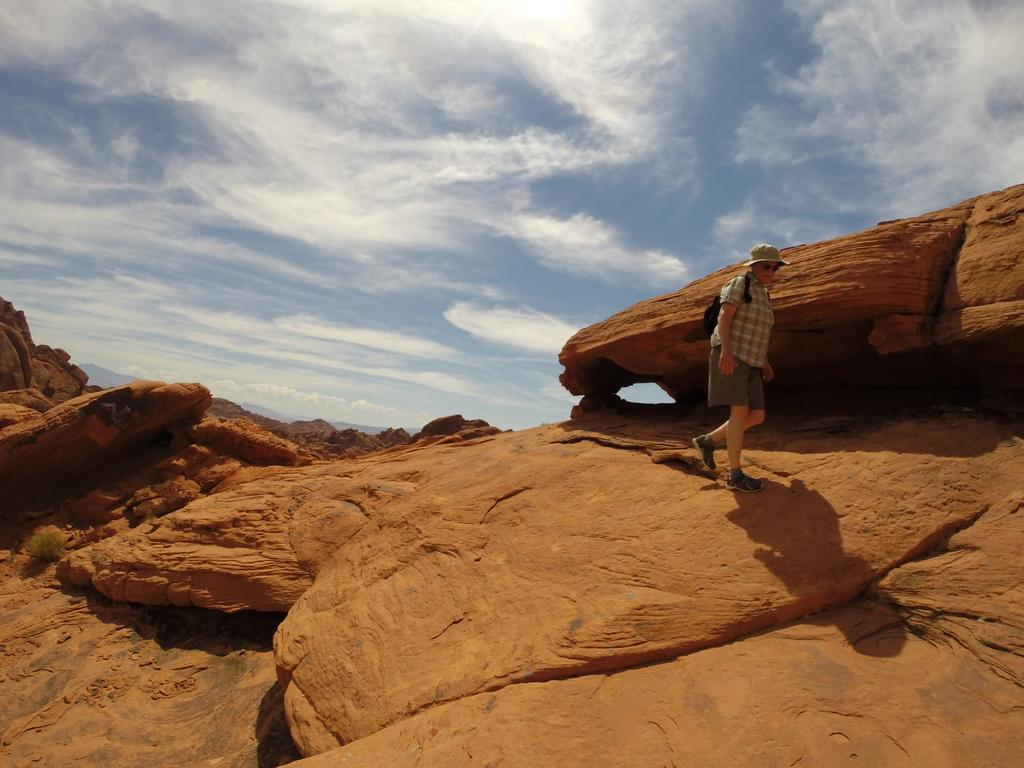What is the main subject of the image? There is a person standing in the image. What type of natural formation can be seen in the image? There are rocks in the image. What can be seen in the background of the image? The sky is visible in the background of the image. Can you describe the yak grazing near the rocks in the image? There is no yak present in the image; it only features a person standing and rocks. 